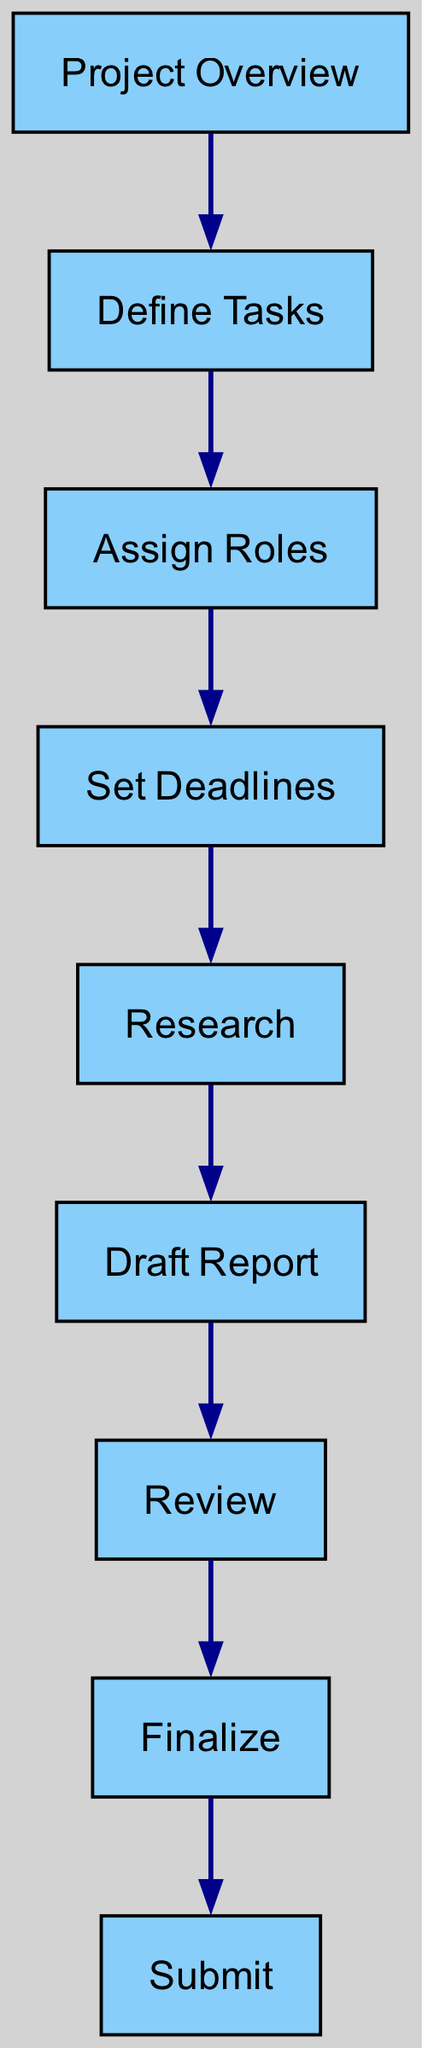What is the starting point of the workflow? The diagram shows that the first node is "Project Overview," which is the initial step in the task management workflow.
Answer: Project Overview How many nodes are there in total? The diagram lists out eight nodes, which include all the different stages of the task management workflow from the project overview to submission.
Answer: 8 Which node comes after "Review"? In the diagram, the edge leading from "Review" points to the next node, which is "Finalize." Thus, the node following "Review" is "Finalize."
Answer: Finalize What role does "Set Deadlines" play in the workflow? "Set Deadlines" is a crucial step that comes after "Assign Roles" and it indicates when tasks need to be completed in the project timeline.
Answer: Key Step How many edges connect the nodes in the diagram? The diagram indicates there are eight edges connecting the various nodes, representing the workflow sequence from start to finish.
Answer: 8 What is the relationship between "Draft Report" and "Submit"? The diagram shows a directional edge from "Draft Report" to "Review" and subsequently to "Finalize," which eventually leads to "Submit," indicating that "Draft Report" must be completed before submitting.
Answer: Sequential Relationship Which task directly follows "Research"? According to the diagram, "Research" is directly connected via an edge to "Draft Report," indicating that "Draft Report" is the next task to follow after conducting research.
Answer: Draft Report What is the endpoint of the workflow? The final node in the directed graph is "Submit," indicating that this is the last step in the task management workflow for the group project.
Answer: Submit What is the fourth node in the task management workflow sequence? By counting through the nodes following the connections in the diagram, the fourth node is "Set Deadlines," which comes after "Assign Roles."
Answer: Set Deadlines What nodes are connected to "Finalize"? The diagram shows that the only node connected to "Finalize" is "Review," indicating that the "Finalize" task follows the review stage of the project.
Answer: Review 